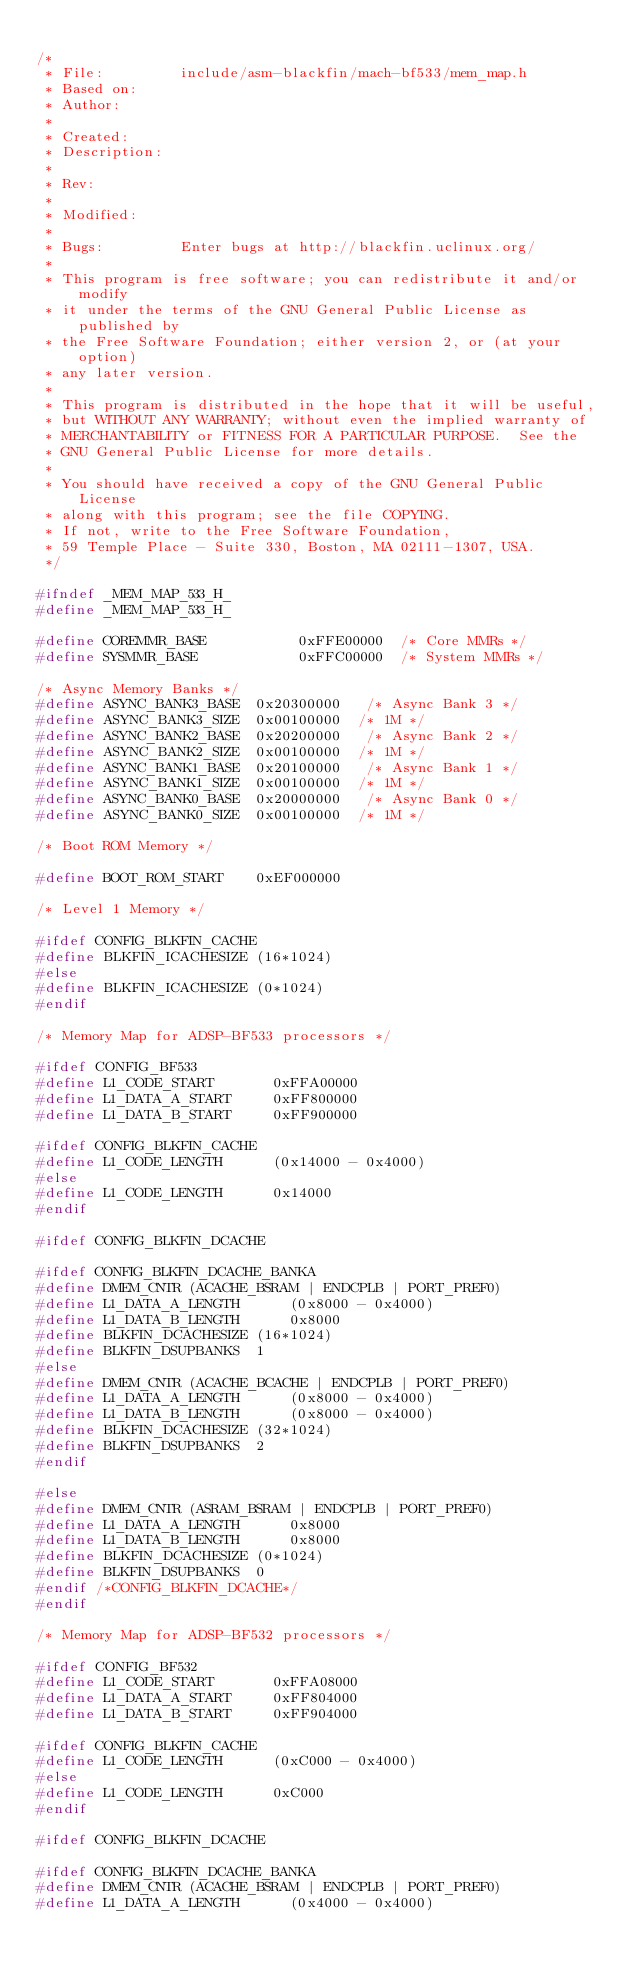Convert code to text. <code><loc_0><loc_0><loc_500><loc_500><_C_>
/*
 * File:         include/asm-blackfin/mach-bf533/mem_map.h
 * Based on:
 * Author:
 *
 * Created:
 * Description:
 *
 * Rev:
 *
 * Modified:
 *
 * Bugs:         Enter bugs at http://blackfin.uclinux.org/
 *
 * This program is free software; you can redistribute it and/or modify
 * it under the terms of the GNU General Public License as published by
 * the Free Software Foundation; either version 2, or (at your option)
 * any later version.
 *
 * This program is distributed in the hope that it will be useful,
 * but WITHOUT ANY WARRANTY; without even the implied warranty of
 * MERCHANTABILITY or FITNESS FOR A PARTICULAR PURPOSE.  See the
 * GNU General Public License for more details.
 *
 * You should have received a copy of the GNU General Public License
 * along with this program; see the file COPYING.
 * If not, write to the Free Software Foundation,
 * 59 Temple Place - Suite 330, Boston, MA 02111-1307, USA.
 */

#ifndef _MEM_MAP_533_H_
#define _MEM_MAP_533_H_

#define COREMMR_BASE           0xFFE00000	 /* Core MMRs */
#define SYSMMR_BASE            0xFFC00000	 /* System MMRs */

/* Async Memory Banks */
#define ASYNC_BANK3_BASE	0x20300000	 /* Async Bank 3 */
#define ASYNC_BANK3_SIZE	0x00100000	/* 1M */
#define ASYNC_BANK2_BASE	0x20200000	 /* Async Bank 2 */
#define ASYNC_BANK2_SIZE	0x00100000	/* 1M */
#define ASYNC_BANK1_BASE	0x20100000	 /* Async Bank 1 */
#define ASYNC_BANK1_SIZE	0x00100000	/* 1M */
#define ASYNC_BANK0_BASE	0x20000000	 /* Async Bank 0 */
#define ASYNC_BANK0_SIZE	0x00100000	/* 1M */

/* Boot ROM Memory */

#define BOOT_ROM_START		0xEF000000

/* Level 1 Memory */

#ifdef CONFIG_BLKFIN_CACHE
#define BLKFIN_ICACHESIZE	(16*1024)
#else
#define BLKFIN_ICACHESIZE	(0*1024)
#endif

/* Memory Map for ADSP-BF533 processors */

#ifdef CONFIG_BF533
#define L1_CODE_START       0xFFA00000
#define L1_DATA_A_START     0xFF800000
#define L1_DATA_B_START     0xFF900000

#ifdef CONFIG_BLKFIN_CACHE
#define L1_CODE_LENGTH      (0x14000 - 0x4000)
#else
#define L1_CODE_LENGTH      0x14000
#endif

#ifdef CONFIG_BLKFIN_DCACHE

#ifdef CONFIG_BLKFIN_DCACHE_BANKA
#define DMEM_CNTR (ACACHE_BSRAM | ENDCPLB | PORT_PREF0)
#define L1_DATA_A_LENGTH      (0x8000 - 0x4000)
#define L1_DATA_B_LENGTH      0x8000
#define BLKFIN_DCACHESIZE	(16*1024)
#define BLKFIN_DSUPBANKS	1
#else
#define DMEM_CNTR (ACACHE_BCACHE | ENDCPLB | PORT_PREF0)
#define L1_DATA_A_LENGTH      (0x8000 - 0x4000)
#define L1_DATA_B_LENGTH      (0x8000 - 0x4000)
#define BLKFIN_DCACHESIZE	(32*1024)
#define BLKFIN_DSUPBANKS	2
#endif

#else
#define DMEM_CNTR (ASRAM_BSRAM | ENDCPLB | PORT_PREF0)
#define L1_DATA_A_LENGTH      0x8000
#define L1_DATA_B_LENGTH      0x8000
#define BLKFIN_DCACHESIZE	(0*1024)
#define BLKFIN_DSUPBANKS	0
#endif /*CONFIG_BLKFIN_DCACHE*/
#endif

/* Memory Map for ADSP-BF532 processors */

#ifdef CONFIG_BF532
#define L1_CODE_START       0xFFA08000
#define L1_DATA_A_START     0xFF804000
#define L1_DATA_B_START     0xFF904000

#ifdef CONFIG_BLKFIN_CACHE
#define L1_CODE_LENGTH      (0xC000 - 0x4000)
#else
#define L1_CODE_LENGTH      0xC000
#endif

#ifdef CONFIG_BLKFIN_DCACHE

#ifdef CONFIG_BLKFIN_DCACHE_BANKA
#define DMEM_CNTR (ACACHE_BSRAM | ENDCPLB | PORT_PREF0)
#define L1_DATA_A_LENGTH      (0x4000 - 0x4000)</code> 